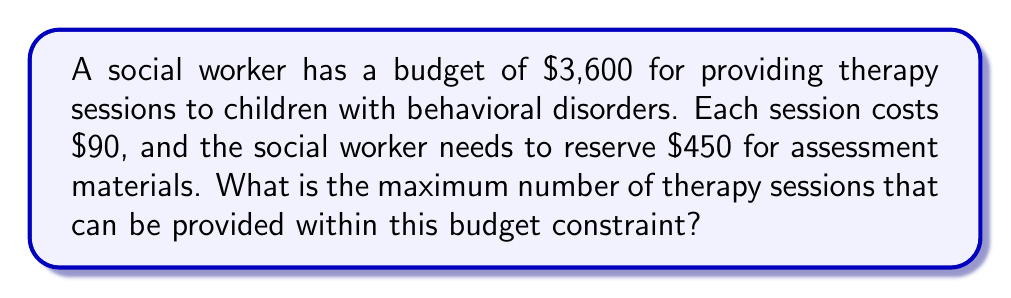Solve this math problem. Let's approach this step-by-step:

1) First, we need to determine the amount available for therapy sessions:
   Total budget: $3,600
   Amount for assessment materials: $450
   
   Amount available for sessions = $3,600 - $450 = $3,150

2) Now, we know that each session costs $90. To find the maximum number of sessions, we need to divide the available amount by the cost per session:

   $$\text{Maximum number of sessions} = \frac{\text{Amount available for sessions}}{\text{Cost per session}}$$

3) Substituting the values:

   $$\text{Maximum number of sessions} = \frac{3150}{90} = 35$$

4) Since we can't have a fractional number of sessions, we round down to the nearest whole number.

Therefore, the maximum number of therapy sessions that can be provided is 35.
Answer: 35 sessions 